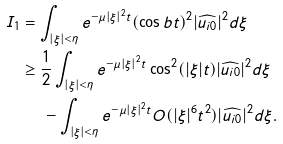<formula> <loc_0><loc_0><loc_500><loc_500>I _ { 1 } & = \int _ { | \xi | < \eta } e ^ { - \mu | \xi | ^ { 2 } t } ( \cos b t ) ^ { 2 } | \widehat { u _ { i 0 } } | ^ { 2 } d \xi \\ & \geq \frac { 1 } { 2 } \int _ { | \xi | < \eta } e ^ { - \mu | \xi | ^ { 2 } t } \cos ^ { 2 } ( | \xi | t ) | \widehat { u _ { i 0 } } | ^ { 2 } d \xi \\ & \quad \ - \int _ { | \xi | < \eta } e ^ { - \mu | \xi | ^ { 2 } t } O ( | \xi | ^ { 6 } t ^ { 2 } ) | \widehat { u _ { i 0 } } | ^ { 2 } d \xi .</formula> 